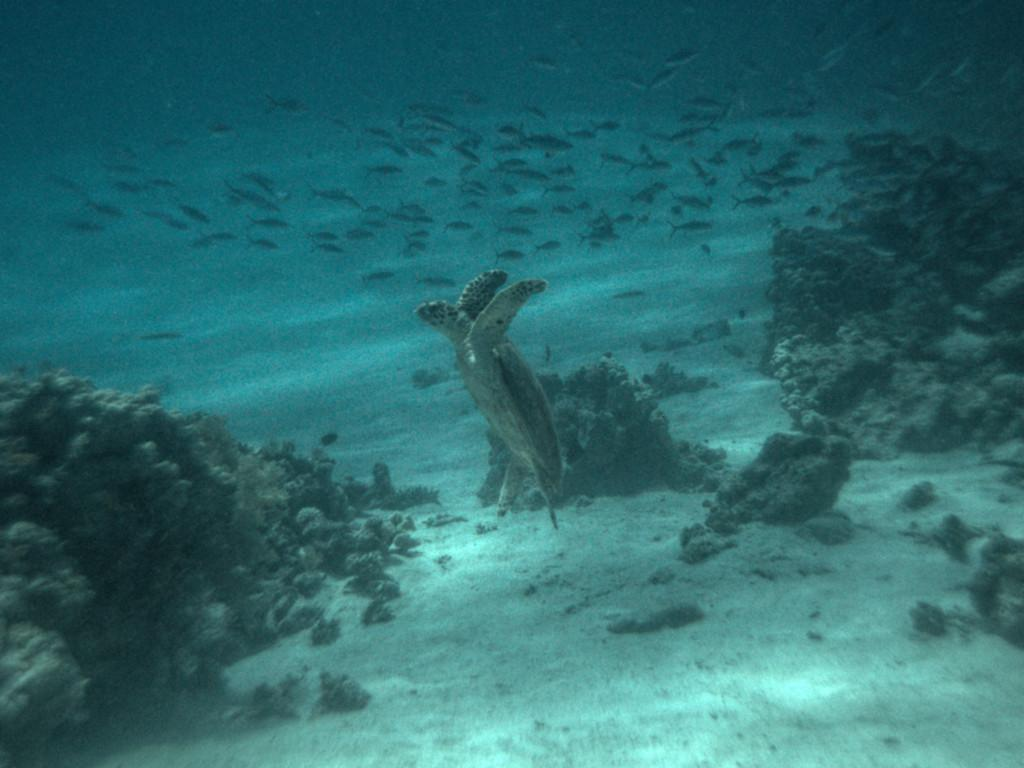What type of animals can be seen in the image? There are many fishes and a turtle in the image. What is the primary element in which the animals are situated? The animals are situated in water, which is visible in the image. What other objects or features can be seen in the image? There are rocks in the image. What color is the kitten's tongue in the image? There is no kitten present in the image, so it is not possible to determine the color of its tongue. 